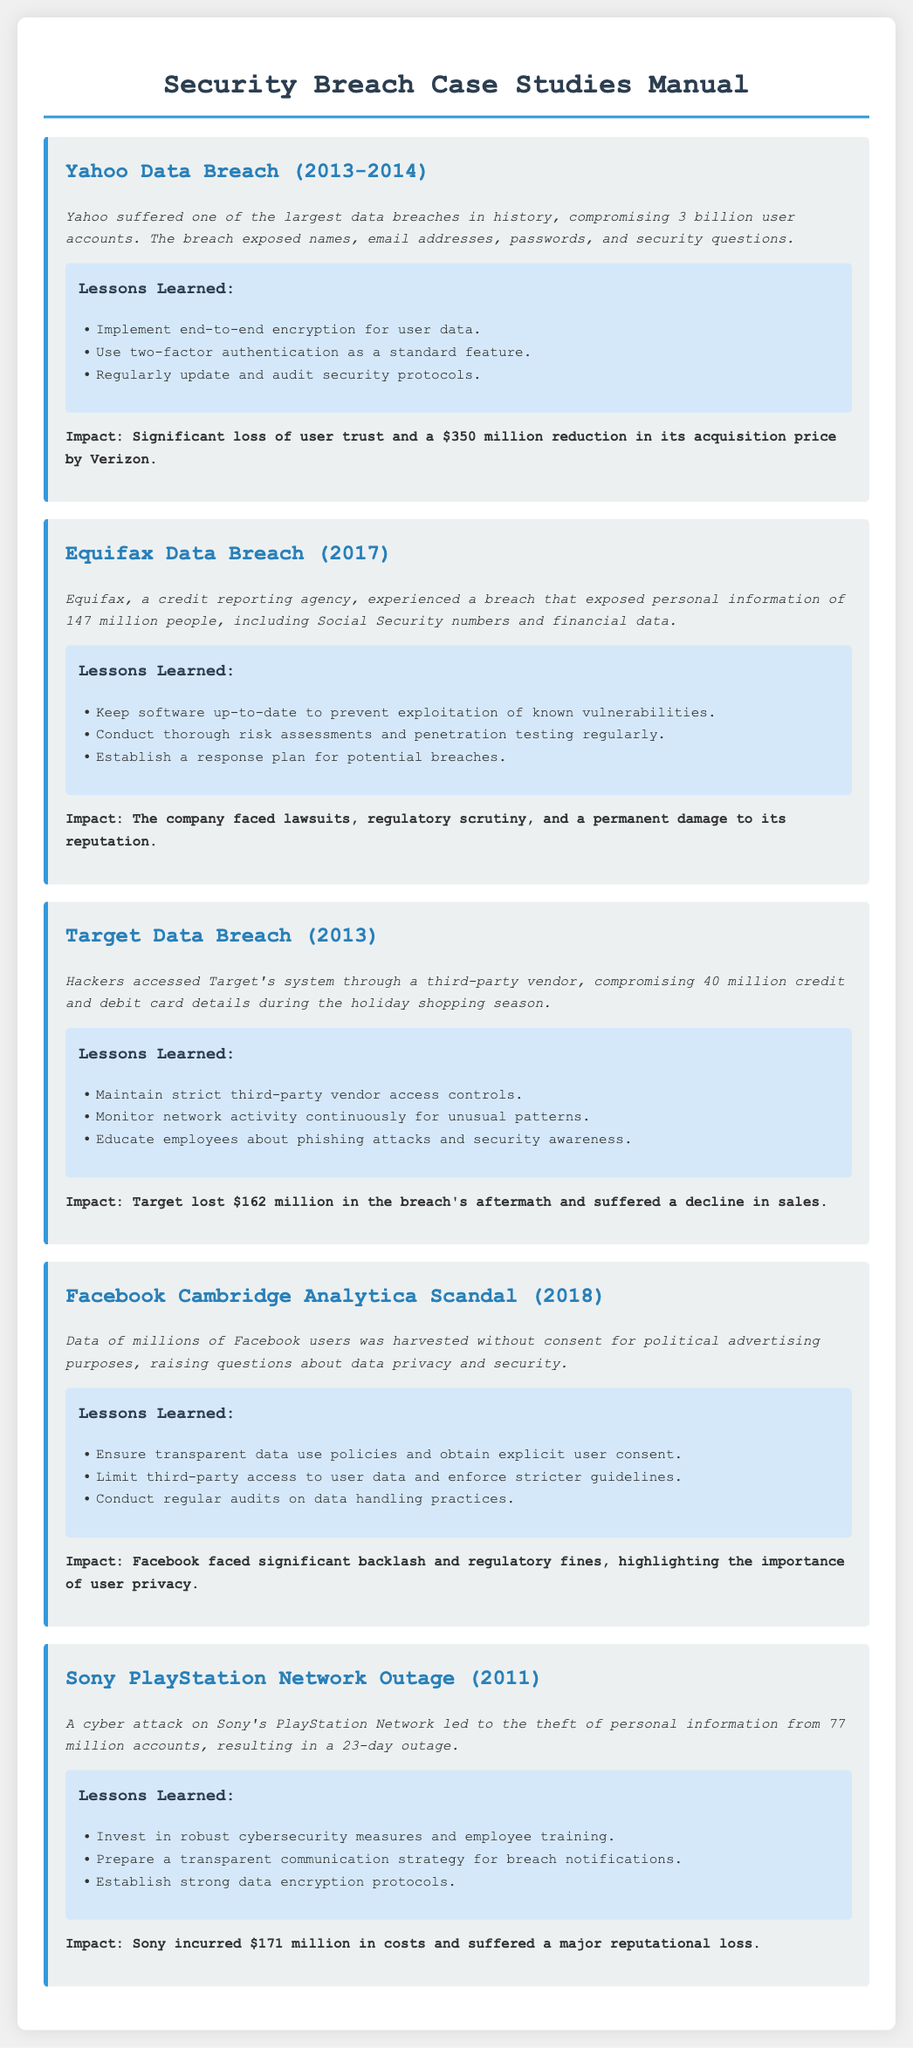what was the year of the Yahoo data breach? The Yahoo data breach occurred in 2013-2014, as indicated in the case study.
Answer: 2013-2014 how many user accounts were compromised in the Yahoo breach? The case study specifically mentions that 3 billion user accounts were compromised.
Answer: 3 billion what major data was exposed in the Equifax breach? The case study lists personal information such as Social Security numbers and financial data as exposed.
Answer: Social Security numbers and financial data what important lesson was learned from the Target data breach regarding third-party vendors? The lessons learned from the Target breach include the importance of maintaining strict third-party vendor access controls.
Answer: Maintain strict third-party vendor access controls what was the financial loss that Target faced after the breach? The document states that Target lost $162 million due to the breach's aftermath.
Answer: $162 million what was the impact of the Facebook Cambridge Analytica scandal? The impact mentioned includes significant backlash and regulatory fines, emphasizing user privacy importance.
Answer: Backlash and regulatory fines how many accounts were affected in the Sony PlayStation Network outage? The case study indicates that 77 million accounts were affected by the outage.
Answer: 77 million what is one lesson learned from the Equifax breach regarding software? A lesson learned was to keep software up-to-date to prevent exploitation.
Answer: Keep software up-to-date what type of document is this? The document is a manual that presents case studies on security breaches and lessons learned.
Answer: Manual 